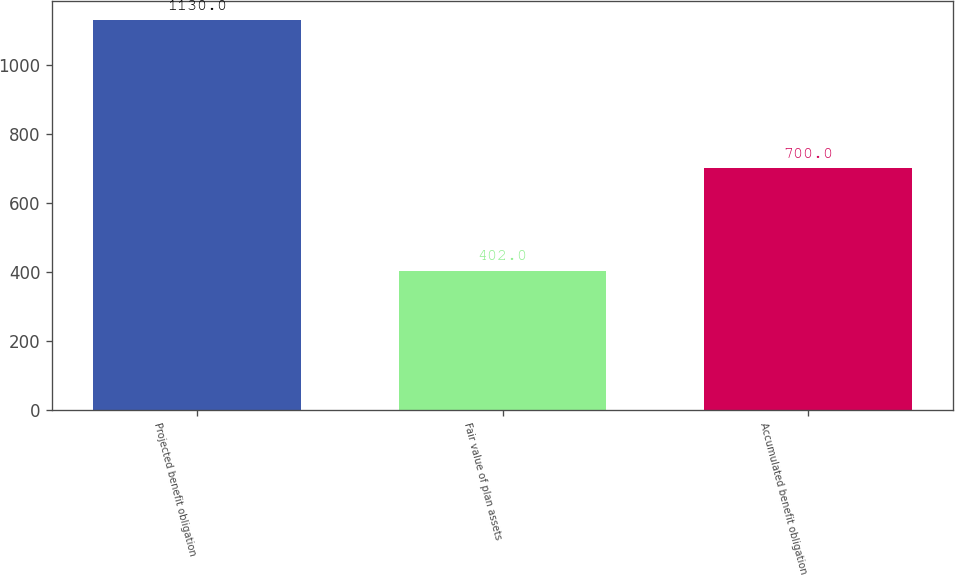Convert chart. <chart><loc_0><loc_0><loc_500><loc_500><bar_chart><fcel>Projected benefit obligation<fcel>Fair value of plan assets<fcel>Accumulated benefit obligation<nl><fcel>1130<fcel>402<fcel>700<nl></chart> 